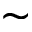<formula> <loc_0><loc_0><loc_500><loc_500>\sim</formula> 